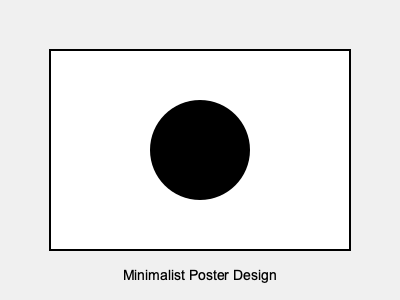Analyze the effectiveness of negative space in this minimalist poster design. How does it contribute to the overall composition and visual impact? To evaluate the use of negative space in this minimalist poster design, we need to consider several aspects:

1. Balance: The negative space (white area) creates a balanced composition by surrounding the central circular element. This balance contributes to a sense of harmony and stability in the design.

2. Focus: The large amount of negative space directs the viewer's attention to the single black circle in the center. This use of negative space effectively emphasizes the main element of the design.

3. Simplicity: The extensive use of negative space reinforces the minimalist approach, creating a clean and uncluttered design that aligns with minimalist principles.

4. Contrast: The stark contrast between the black circle and the white background (negative space) creates a strong visual impact, making the design more memorable and eye-catching.

5. Breathing room: The negative space provides ample "breathing room" around the central element, preventing the design from feeling crowded or overwhelming.

6. Implied space: The negative space implies a larger context or environment for the central element, allowing viewers to interpret and engage with the design more actively.

7. Proportion: The ratio of negative space to positive space (approximately 80:20) creates a visually pleasing composition that adheres to the principles of good design.

8. Framing: The negative space acts as a natural frame for the central element, drawing the eye inward and creating a sense of depth and dimension.

The effective use of negative space in this design demonstrates a strong understanding of composition principles and the power of simplicity in visual communication.
Answer: The negative space effectively balances the composition, focuses attention on the central element, reinforces minimalism, creates contrast, provides breathing room, implies context, maintains pleasing proportions, and frames the design, resulting in a strong visual impact. 